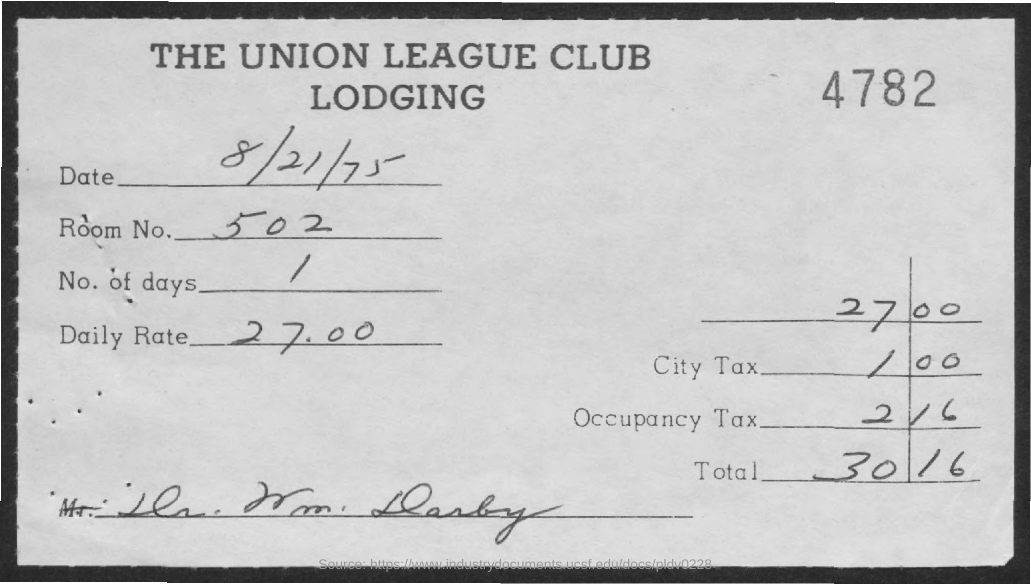What is the name of the lodging given in the document?
Provide a succinct answer. THE UNION LEAGUE CLUB LODGING. What is the date mentioned in this document?
Provide a short and direct response. 8/21/75. What is the Room No. mentioned in the document?
Provide a short and direct response. 502. What is the No. of days given in the document?
Offer a very short reply. 1. What is the daily rate mentioned in the document?
Your response must be concise. 27.00. 